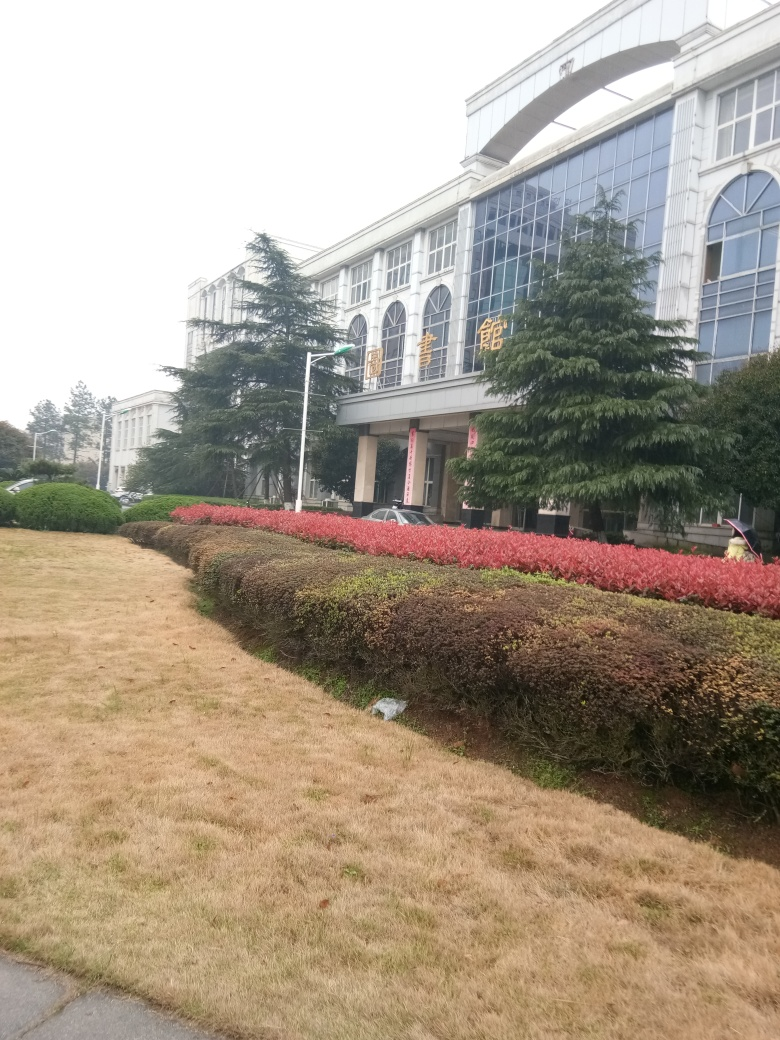What can be inferred about the weather or season when this photo was taken? The overcast sky and the state of the grass suggest that the photo may have been taken during a dry season or amidst dormant vegetation periods, which can occur in late fall or winter in some climates. The lack of activity and leafless tree indicate it might not be a warm season. 